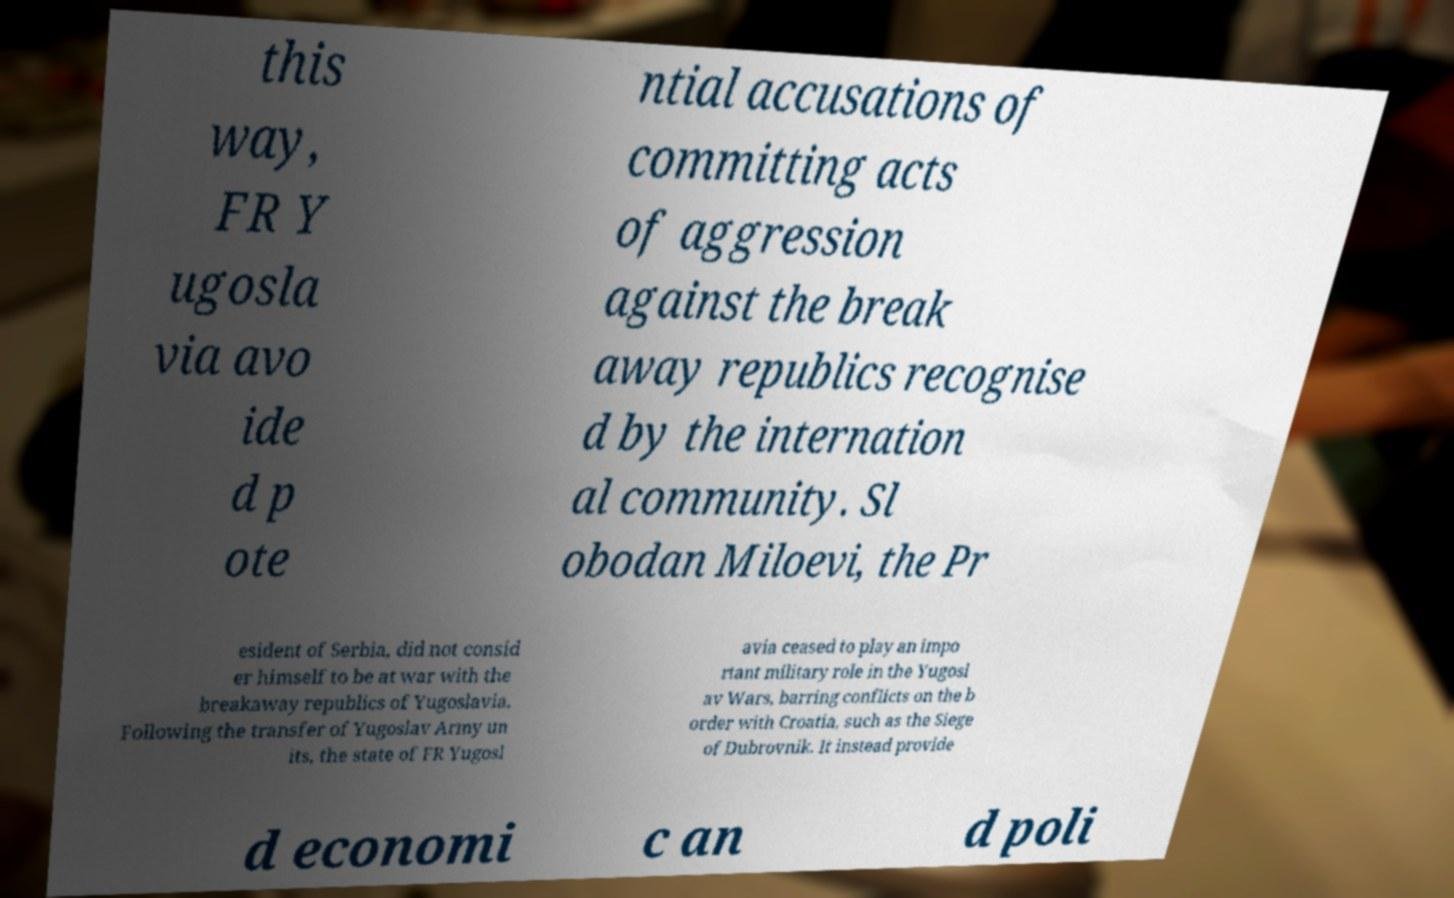Could you assist in decoding the text presented in this image and type it out clearly? this way, FR Y ugosla via avo ide d p ote ntial accusations of committing acts of aggression against the break away republics recognise d by the internation al community. Sl obodan Miloevi, the Pr esident of Serbia, did not consid er himself to be at war with the breakaway republics of Yugoslavia. Following the transfer of Yugoslav Army un its, the state of FR Yugosl avia ceased to play an impo rtant military role in the Yugosl av Wars, barring conflicts on the b order with Croatia, such as the Siege of Dubrovnik. It instead provide d economi c an d poli 